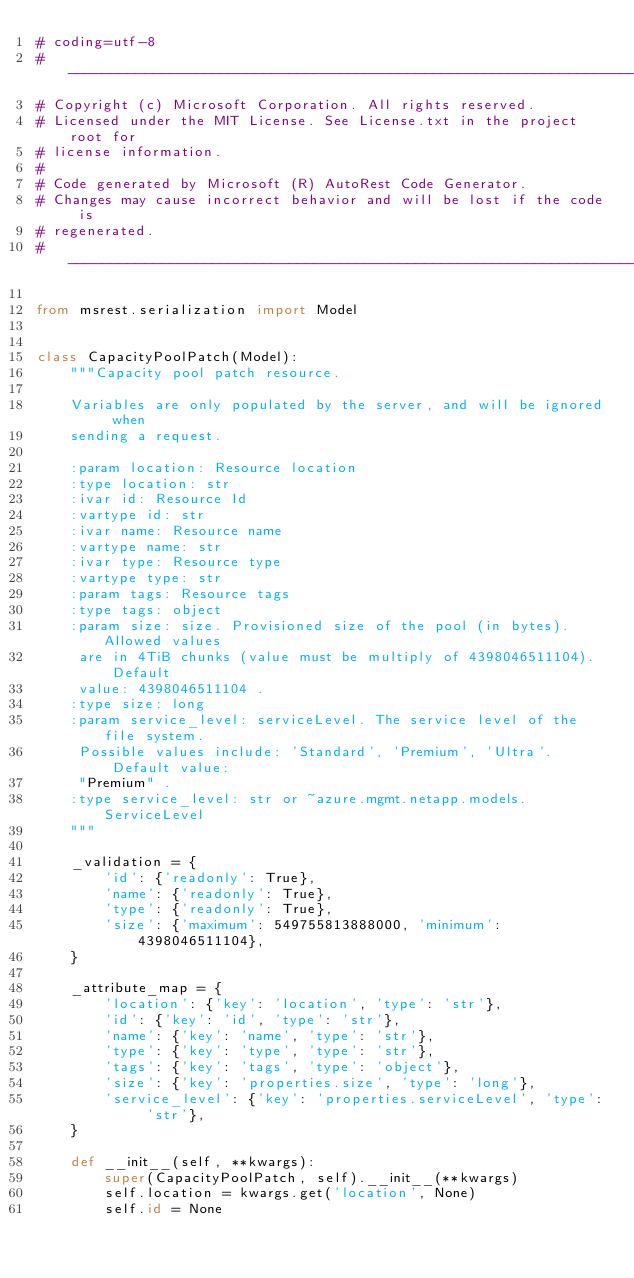Convert code to text. <code><loc_0><loc_0><loc_500><loc_500><_Python_># coding=utf-8
# --------------------------------------------------------------------------
# Copyright (c) Microsoft Corporation. All rights reserved.
# Licensed under the MIT License. See License.txt in the project root for
# license information.
#
# Code generated by Microsoft (R) AutoRest Code Generator.
# Changes may cause incorrect behavior and will be lost if the code is
# regenerated.
# --------------------------------------------------------------------------

from msrest.serialization import Model


class CapacityPoolPatch(Model):
    """Capacity pool patch resource.

    Variables are only populated by the server, and will be ignored when
    sending a request.

    :param location: Resource location
    :type location: str
    :ivar id: Resource Id
    :vartype id: str
    :ivar name: Resource name
    :vartype name: str
    :ivar type: Resource type
    :vartype type: str
    :param tags: Resource tags
    :type tags: object
    :param size: size. Provisioned size of the pool (in bytes). Allowed values
     are in 4TiB chunks (value must be multiply of 4398046511104). Default
     value: 4398046511104 .
    :type size: long
    :param service_level: serviceLevel. The service level of the file system.
     Possible values include: 'Standard', 'Premium', 'Ultra'. Default value:
     "Premium" .
    :type service_level: str or ~azure.mgmt.netapp.models.ServiceLevel
    """

    _validation = {
        'id': {'readonly': True},
        'name': {'readonly': True},
        'type': {'readonly': True},
        'size': {'maximum': 549755813888000, 'minimum': 4398046511104},
    }

    _attribute_map = {
        'location': {'key': 'location', 'type': 'str'},
        'id': {'key': 'id', 'type': 'str'},
        'name': {'key': 'name', 'type': 'str'},
        'type': {'key': 'type', 'type': 'str'},
        'tags': {'key': 'tags', 'type': 'object'},
        'size': {'key': 'properties.size', 'type': 'long'},
        'service_level': {'key': 'properties.serviceLevel', 'type': 'str'},
    }

    def __init__(self, **kwargs):
        super(CapacityPoolPatch, self).__init__(**kwargs)
        self.location = kwargs.get('location', None)
        self.id = None</code> 